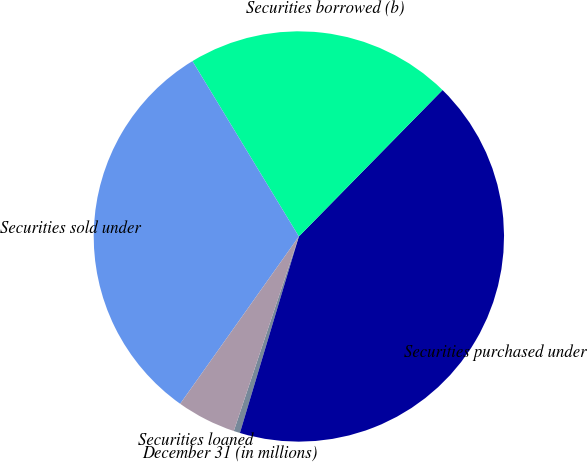Convert chart. <chart><loc_0><loc_0><loc_500><loc_500><pie_chart><fcel>December 31 (in millions)<fcel>Securities purchased under<fcel>Securities borrowed (b)<fcel>Securities sold under<fcel>Securities loaned<nl><fcel>0.5%<fcel>42.29%<fcel>21.03%<fcel>31.5%<fcel>4.68%<nl></chart> 